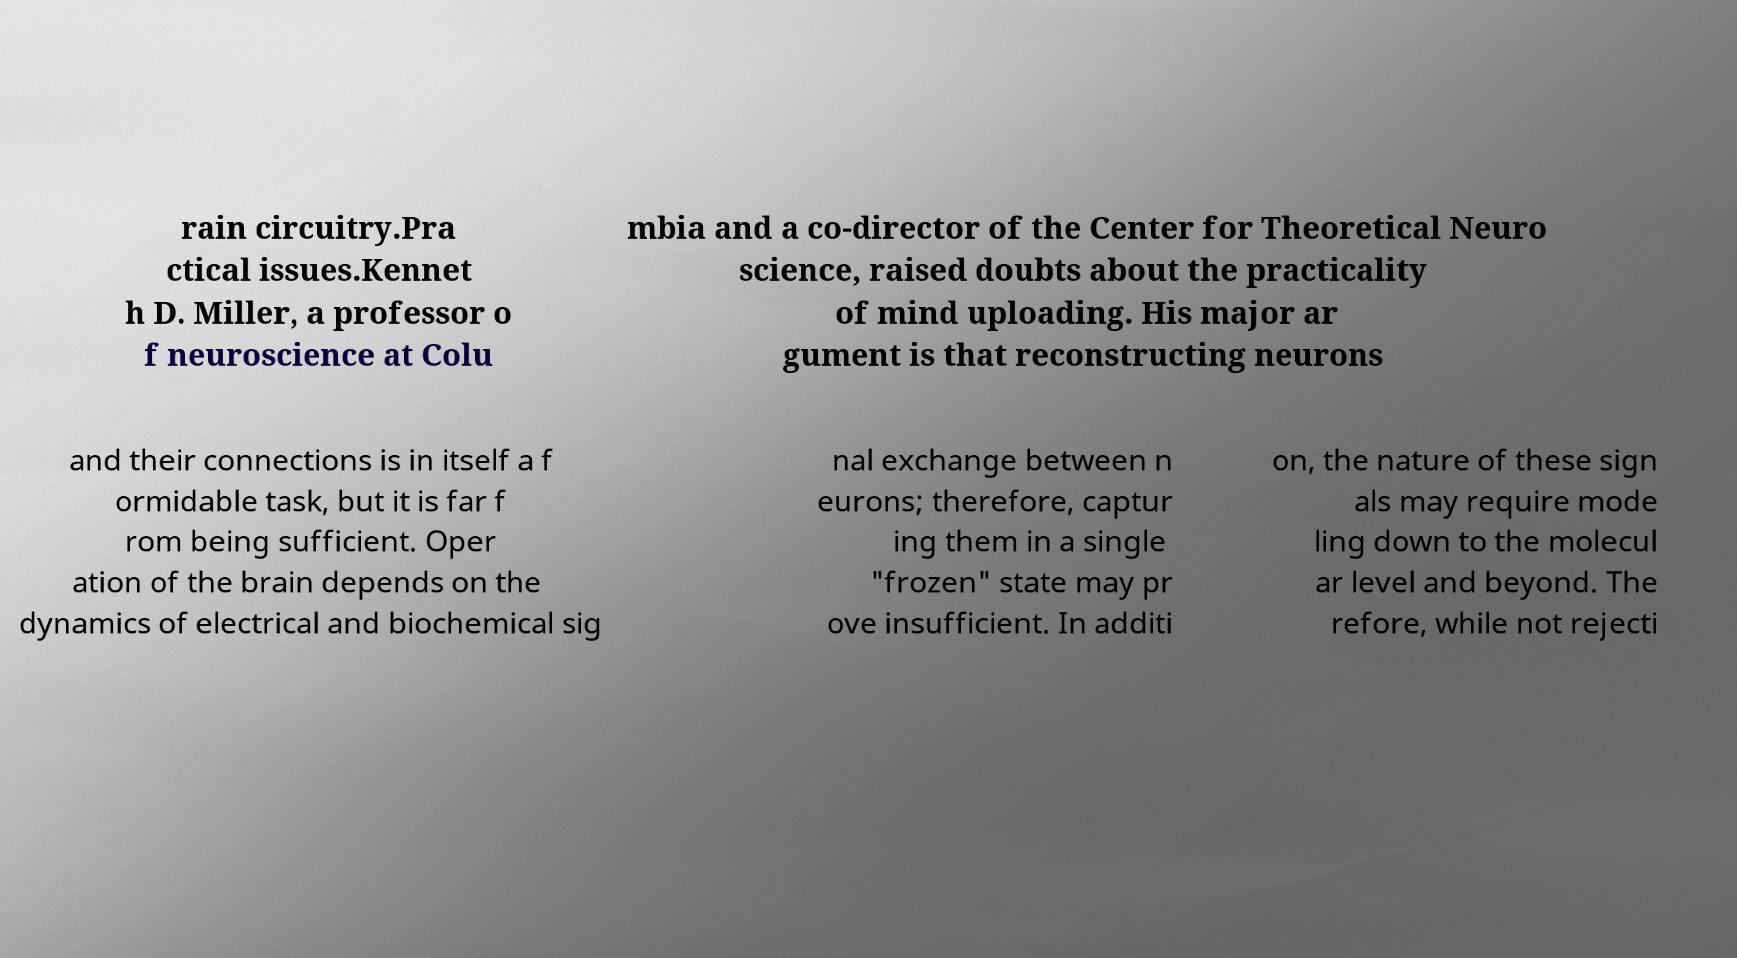Can you accurately transcribe the text from the provided image for me? rain circuitry.Pra ctical issues.Kennet h D. Miller, a professor o f neuroscience at Colu mbia and a co-director of the Center for Theoretical Neuro science, raised doubts about the practicality of mind uploading. His major ar gument is that reconstructing neurons and their connections is in itself a f ormidable task, but it is far f rom being sufficient. Oper ation of the brain depends on the dynamics of electrical and biochemical sig nal exchange between n eurons; therefore, captur ing them in a single "frozen" state may pr ove insufficient. In additi on, the nature of these sign als may require mode ling down to the molecul ar level and beyond. The refore, while not rejecti 